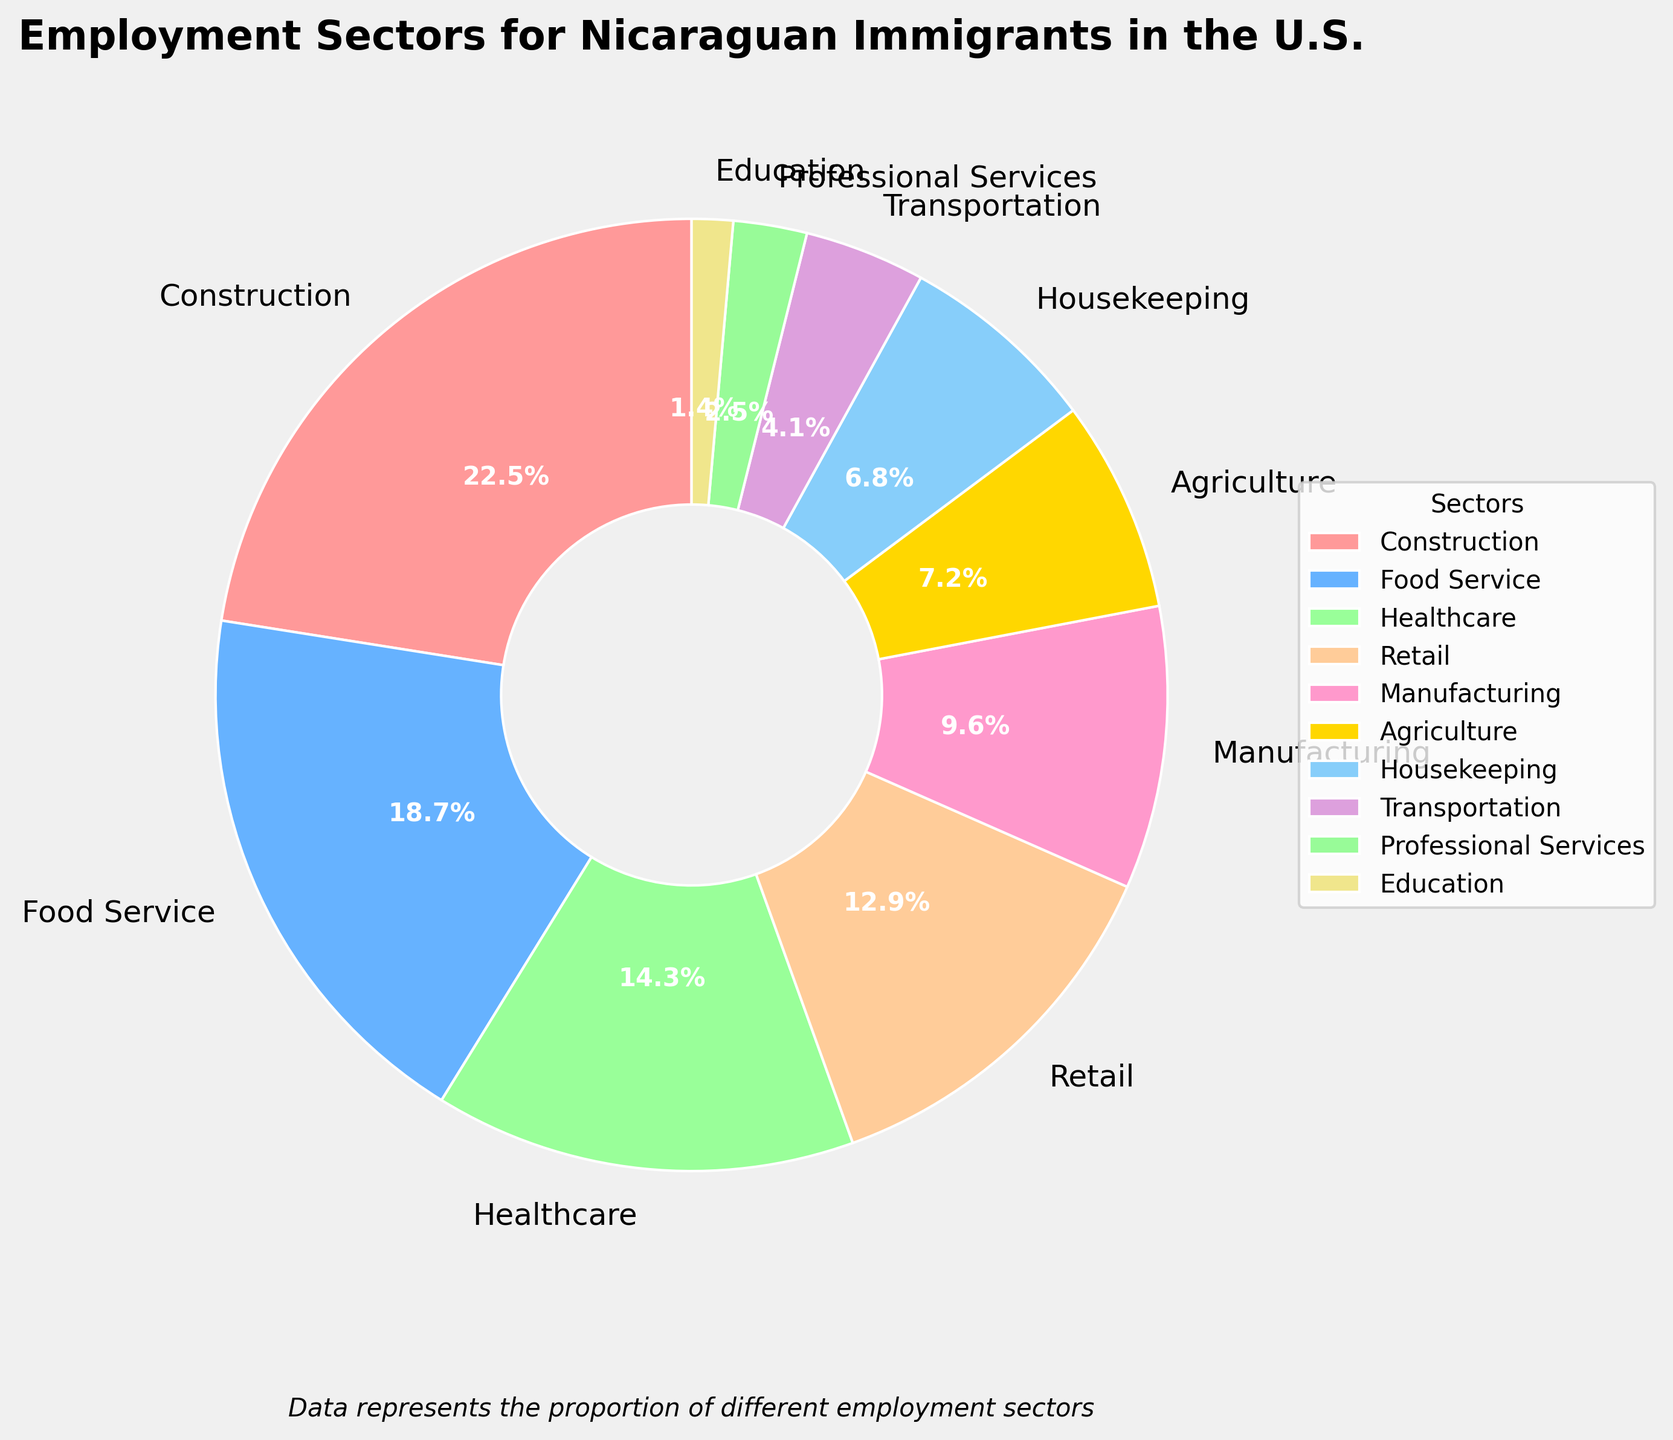What is the percentage of Nicaraguan immigrants working in the Construction sector? The Construction sector is labeled on the pie chart with its respective percentage. By examining the chart, we see that the percentage for the Construction sector is shown.
Answer: 22.5% Which employment sector has the smallest representation among Nicaraguan immigrants? By looking at the pie chart, the Education sector has the smallest slice, indicating it has the smallest percentage. The exact percentage is 1.4%.
Answer: Education Which sector employs more Nicaraguan immigrants, Manufacturing or Agriculture? Compare the sizes of the slices for Manufacturing and Agriculture on the pie chart. Manufacturing has a larger slice compared to Agriculture.
Answer: Manufacturing What is the combined percentage of Nicaraguan immigrants working in Healthcare and Retail? Add the percentages for Healthcare (14.3%) and Retail (12.9%). 14.3% + 12.9% = 27.2%.
Answer: 27.2% How many sectors employ more than 10% of Nicaraguan immigrants? Identify the sectors with percentages greater than 10% on the pie chart. Construction, Food Service, Healthcare, and Retail all have percentages higher than 10%. Count these sectors.
Answer: 4 Which sector employs fewer Nicaraguan immigrants, Housekeeping or Transportation? Compare the sizes of the slices for Housekeeping and Transportation on the pie chart. Transportation has a smaller slice than Housekeeping.
Answer: Transportation What is the percentage difference between the largest and smallest employment sectors? The largest sector is Construction at 22.5%, and the smallest sector is Education at 1.4%. Subtract the smallest percentage from the largest: 22.5% - 1.4% = 21.1%.
Answer: 21.1% If the percentages for Construction and Retail are combined, would they represent more than a third of all sectors? Add the percentages for Construction (22.5%) and Retail (12.9%). Combined, they equal 35.4%. Since a third is approximately 33.3%, the combined percentage is greater than a third.
Answer: Yes Which sector represents the third largest proportion of employment for Nicaraguan immigrants? From the largest to smallest, the percentages are: Construction, Food Service, Healthcare. Healthcare is the third largest.
Answer: Healthcare By what margin does the Food Service sector surpass the Healthcare sector in percentage? Subtract the Healthcare sector's percentage (14.3%) from the Food Service sector's percentage (18.7%). The difference is 18.7% - 14.3% = 4.4%.
Answer: 4.4% 